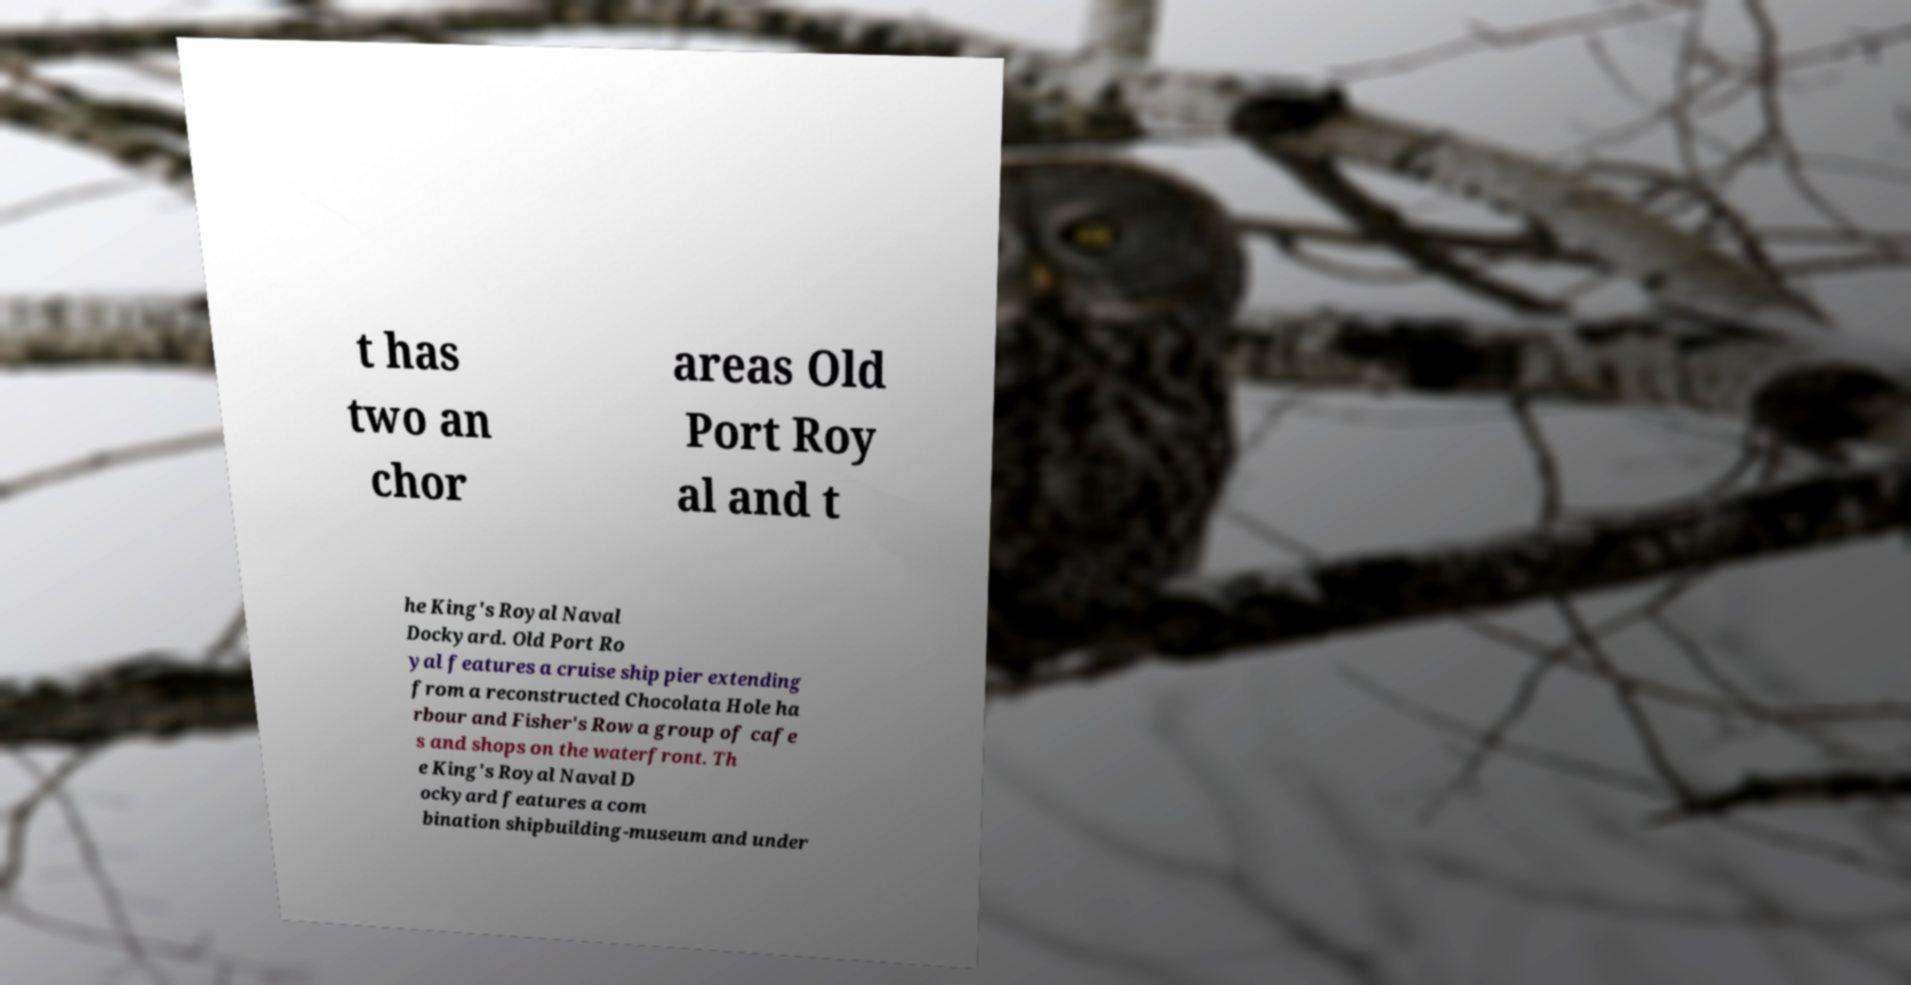Could you assist in decoding the text presented in this image and type it out clearly? t has two an chor areas Old Port Roy al and t he King's Royal Naval Dockyard. Old Port Ro yal features a cruise ship pier extending from a reconstructed Chocolata Hole ha rbour and Fisher's Row a group of cafe s and shops on the waterfront. Th e King's Royal Naval D ockyard features a com bination shipbuilding-museum and under 